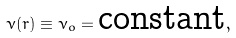<formula> <loc_0><loc_0><loc_500><loc_500>\nu ( r ) \equiv \nu _ { o } = \text {constant} ,</formula> 